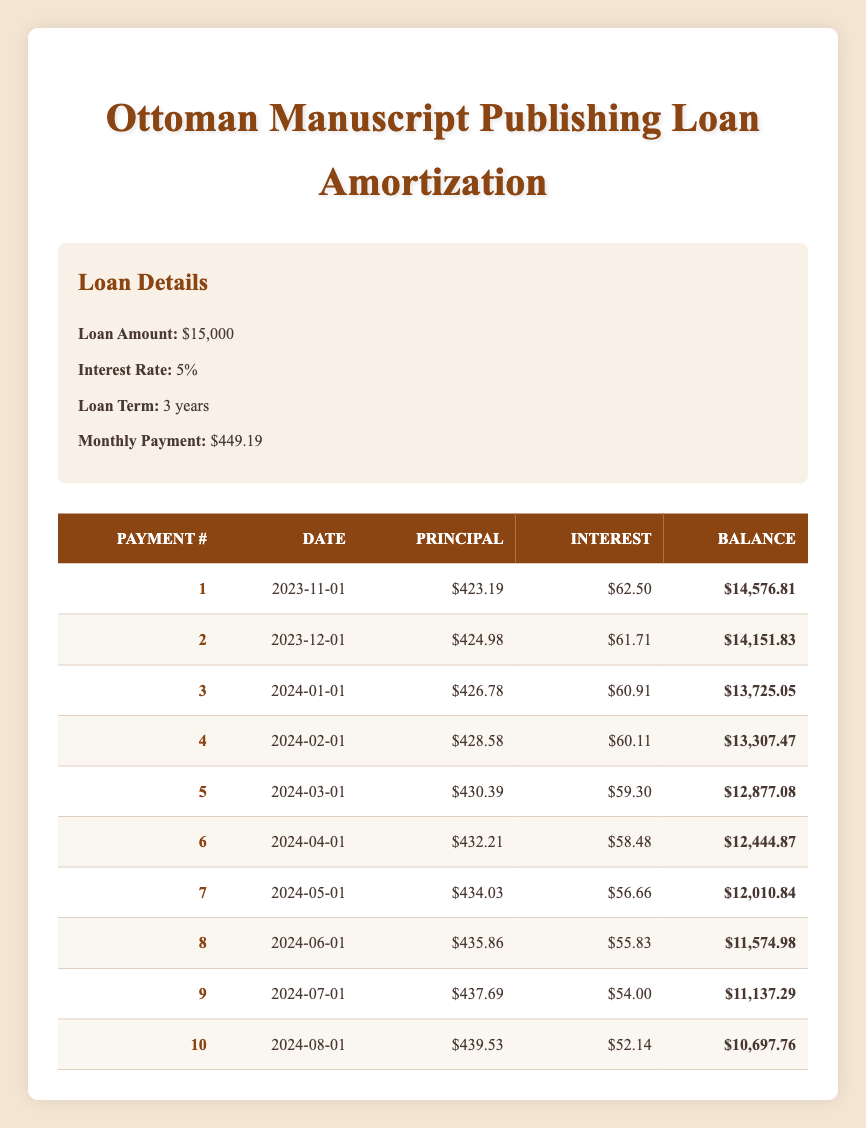What is the total amount paid in interest after the first three payments? To find the total interest paid after the first three payments, we add the interest payments for each of the first three payments: $62.50 (payment 1) + $61.71 (payment 2) + $60.91 (payment 3) = $185.12.
Answer: $185.12 What is the remaining balance after the fifth payment? The remaining balance after the fifth payment is directly given in the table, which shows it as $12,877.08 for payment number 5.
Answer: $12,877.08 Did the principal payments increase over the first ten payments? By examining the principal payment amounts in the first ten rows, we see that they consistently increase from $423.19 to $439.53, indicating that the principal payments do increase.
Answer: Yes What is the average monthly principal payment over the first ten payments? To find the average monthly principal payment, we sum up all principal payments: $423.19 + $424.98 + $426.78 + $428.58 + $430.39 + $432.21 + $434.03 + $435.86 + $437.69 + $439.53 = $4,319.24. Dividing by 10 gives us an average of $431.92.
Answer: $431.92 What is the difference between the interest payment of the first and the last payment? The interest payment for the first payment is $62.50 and for the last (tenth) payment is $52.14. The difference is calculated as $62.50 - $52.14 = $10.36.
Answer: $10.36 What percentage of the total first payment goes toward the principal? The total first payment is the sum of the principal and interest payments: $423.19 (principal) + $62.50 (interest) = $485.69. The percentage of the first payment that goes to the principal is calculated as ($423.19 / $485.69) * 100 = 87.1%.
Answer: 87.1% What is the highest principal payment made in the first ten payments? By reviewing the principal payments from payment 1 through payment 10, the highest principal payment is $439.53 (from payment number 10).
Answer: $439.53 Is the interest payment for the second payment higher than that of the fourth payment? Reviewing the interest payments, the second payment is $61.71 and the fourth payment is $60.11. Since $61.71 is greater, the second payment is indeed higher.
Answer: Yes 